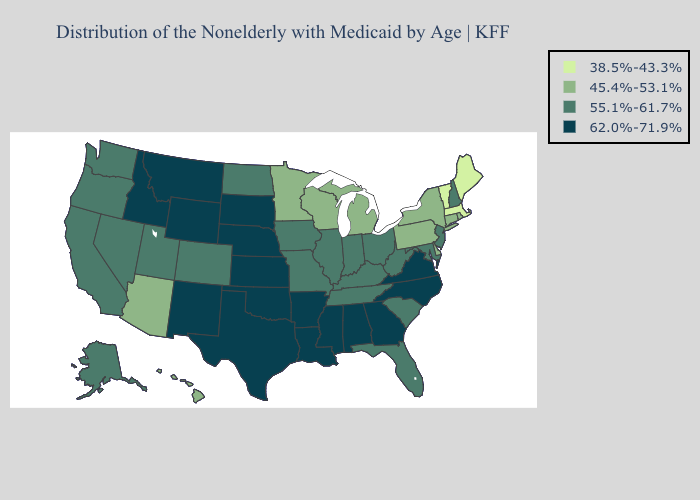Does Missouri have the highest value in the MidWest?
Quick response, please. No. Among the states that border Illinois , which have the lowest value?
Give a very brief answer. Wisconsin. Does Ohio have a higher value than New Jersey?
Give a very brief answer. No. Name the states that have a value in the range 55.1%-61.7%?
Answer briefly. Alaska, California, Colorado, Florida, Illinois, Indiana, Iowa, Kentucky, Maryland, Missouri, Nevada, New Hampshire, New Jersey, North Dakota, Ohio, Oregon, South Carolina, Tennessee, Utah, Washington, West Virginia. What is the value of South Dakota?
Be succinct. 62.0%-71.9%. Name the states that have a value in the range 62.0%-71.9%?
Give a very brief answer. Alabama, Arkansas, Georgia, Idaho, Kansas, Louisiana, Mississippi, Montana, Nebraska, New Mexico, North Carolina, Oklahoma, South Dakota, Texas, Virginia, Wyoming. Does West Virginia have a higher value than Pennsylvania?
Write a very short answer. Yes. Among the states that border North Carolina , which have the lowest value?
Quick response, please. South Carolina, Tennessee. What is the lowest value in the Northeast?
Give a very brief answer. 38.5%-43.3%. What is the value of Arkansas?
Write a very short answer. 62.0%-71.9%. Which states have the highest value in the USA?
Answer briefly. Alabama, Arkansas, Georgia, Idaho, Kansas, Louisiana, Mississippi, Montana, Nebraska, New Mexico, North Carolina, Oklahoma, South Dakota, Texas, Virginia, Wyoming. Name the states that have a value in the range 55.1%-61.7%?
Keep it brief. Alaska, California, Colorado, Florida, Illinois, Indiana, Iowa, Kentucky, Maryland, Missouri, Nevada, New Hampshire, New Jersey, North Dakota, Ohio, Oregon, South Carolina, Tennessee, Utah, Washington, West Virginia. How many symbols are there in the legend?
Write a very short answer. 4. Does California have the highest value in the USA?
Be succinct. No. 